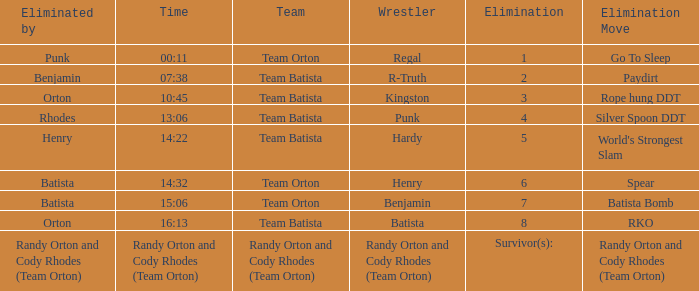Which Elimination Move is listed at Elimination 8 for Team Batista? RKO. 